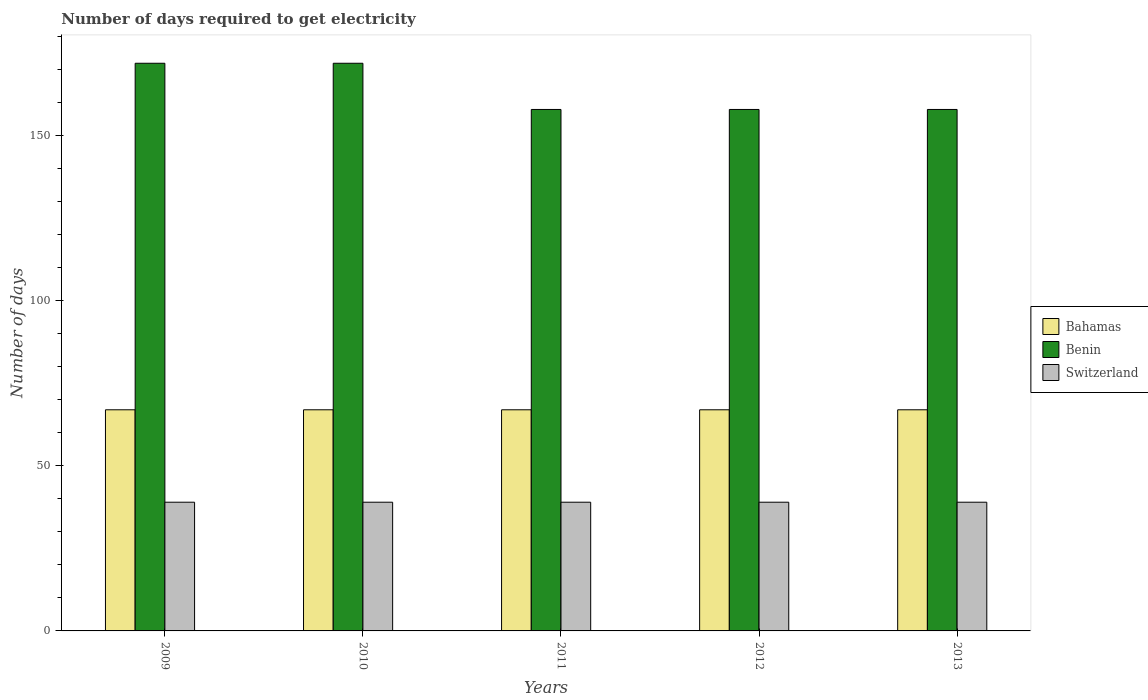How many different coloured bars are there?
Provide a short and direct response. 3. How many groups of bars are there?
Ensure brevity in your answer.  5. How many bars are there on the 3rd tick from the left?
Your response must be concise. 3. What is the number of days required to get electricity in in Benin in 2011?
Your response must be concise. 158. Across all years, what is the maximum number of days required to get electricity in in Bahamas?
Keep it short and to the point. 67. Across all years, what is the minimum number of days required to get electricity in in Bahamas?
Offer a very short reply. 67. What is the total number of days required to get electricity in in Switzerland in the graph?
Give a very brief answer. 195. What is the difference between the number of days required to get electricity in in Benin in 2010 and that in 2012?
Provide a succinct answer. 14. What is the difference between the number of days required to get electricity in in Bahamas in 2011 and the number of days required to get electricity in in Switzerland in 2009?
Offer a terse response. 28. What is the average number of days required to get electricity in in Switzerland per year?
Ensure brevity in your answer.  39. In the year 2012, what is the difference between the number of days required to get electricity in in Benin and number of days required to get electricity in in Switzerland?
Your answer should be compact. 119. In how many years, is the number of days required to get electricity in in Switzerland greater than 140 days?
Ensure brevity in your answer.  0. What is the ratio of the number of days required to get electricity in in Benin in 2010 to that in 2013?
Offer a terse response. 1.09. What is the difference between the highest and the lowest number of days required to get electricity in in Bahamas?
Ensure brevity in your answer.  0. What does the 2nd bar from the left in 2013 represents?
Provide a succinct answer. Benin. What does the 1st bar from the right in 2010 represents?
Make the answer very short. Switzerland. Is it the case that in every year, the sum of the number of days required to get electricity in in Bahamas and number of days required to get electricity in in Benin is greater than the number of days required to get electricity in in Switzerland?
Your answer should be very brief. Yes. How many bars are there?
Make the answer very short. 15. Are all the bars in the graph horizontal?
Your response must be concise. No. How many years are there in the graph?
Your response must be concise. 5. Does the graph contain grids?
Your response must be concise. No. What is the title of the graph?
Your answer should be very brief. Number of days required to get electricity. Does "Oman" appear as one of the legend labels in the graph?
Your answer should be compact. No. What is the label or title of the X-axis?
Provide a succinct answer. Years. What is the label or title of the Y-axis?
Give a very brief answer. Number of days. What is the Number of days in Benin in 2009?
Your answer should be very brief. 172. What is the Number of days in Bahamas in 2010?
Offer a terse response. 67. What is the Number of days in Benin in 2010?
Your answer should be very brief. 172. What is the Number of days of Benin in 2011?
Keep it short and to the point. 158. What is the Number of days of Switzerland in 2011?
Offer a very short reply. 39. What is the Number of days in Bahamas in 2012?
Your answer should be very brief. 67. What is the Number of days of Benin in 2012?
Provide a succinct answer. 158. What is the Number of days of Switzerland in 2012?
Offer a very short reply. 39. What is the Number of days of Benin in 2013?
Give a very brief answer. 158. Across all years, what is the maximum Number of days of Benin?
Make the answer very short. 172. Across all years, what is the minimum Number of days in Benin?
Provide a short and direct response. 158. What is the total Number of days in Bahamas in the graph?
Offer a terse response. 335. What is the total Number of days of Benin in the graph?
Give a very brief answer. 818. What is the total Number of days in Switzerland in the graph?
Your answer should be very brief. 195. What is the difference between the Number of days in Bahamas in 2009 and that in 2010?
Offer a very short reply. 0. What is the difference between the Number of days of Benin in 2009 and that in 2010?
Make the answer very short. 0. What is the difference between the Number of days of Switzerland in 2009 and that in 2010?
Offer a very short reply. 0. What is the difference between the Number of days in Benin in 2009 and that in 2011?
Provide a succinct answer. 14. What is the difference between the Number of days of Benin in 2009 and that in 2012?
Provide a succinct answer. 14. What is the difference between the Number of days of Benin in 2009 and that in 2013?
Provide a succinct answer. 14. What is the difference between the Number of days in Switzerland in 2010 and that in 2011?
Offer a very short reply. 0. What is the difference between the Number of days of Benin in 2010 and that in 2013?
Give a very brief answer. 14. What is the difference between the Number of days of Benin in 2011 and that in 2012?
Your answer should be compact. 0. What is the difference between the Number of days of Benin in 2011 and that in 2013?
Make the answer very short. 0. What is the difference between the Number of days of Switzerland in 2011 and that in 2013?
Offer a terse response. 0. What is the difference between the Number of days of Switzerland in 2012 and that in 2013?
Offer a very short reply. 0. What is the difference between the Number of days in Bahamas in 2009 and the Number of days in Benin in 2010?
Ensure brevity in your answer.  -105. What is the difference between the Number of days in Benin in 2009 and the Number of days in Switzerland in 2010?
Your response must be concise. 133. What is the difference between the Number of days in Bahamas in 2009 and the Number of days in Benin in 2011?
Your response must be concise. -91. What is the difference between the Number of days in Benin in 2009 and the Number of days in Switzerland in 2011?
Keep it short and to the point. 133. What is the difference between the Number of days in Bahamas in 2009 and the Number of days in Benin in 2012?
Your answer should be very brief. -91. What is the difference between the Number of days of Bahamas in 2009 and the Number of days of Switzerland in 2012?
Provide a succinct answer. 28. What is the difference between the Number of days in Benin in 2009 and the Number of days in Switzerland in 2012?
Your answer should be compact. 133. What is the difference between the Number of days in Bahamas in 2009 and the Number of days in Benin in 2013?
Your answer should be very brief. -91. What is the difference between the Number of days of Benin in 2009 and the Number of days of Switzerland in 2013?
Provide a succinct answer. 133. What is the difference between the Number of days of Bahamas in 2010 and the Number of days of Benin in 2011?
Your answer should be compact. -91. What is the difference between the Number of days in Bahamas in 2010 and the Number of days in Switzerland in 2011?
Keep it short and to the point. 28. What is the difference between the Number of days of Benin in 2010 and the Number of days of Switzerland in 2011?
Keep it short and to the point. 133. What is the difference between the Number of days in Bahamas in 2010 and the Number of days in Benin in 2012?
Provide a succinct answer. -91. What is the difference between the Number of days in Bahamas in 2010 and the Number of days in Switzerland in 2012?
Give a very brief answer. 28. What is the difference between the Number of days of Benin in 2010 and the Number of days of Switzerland in 2012?
Keep it short and to the point. 133. What is the difference between the Number of days of Bahamas in 2010 and the Number of days of Benin in 2013?
Offer a terse response. -91. What is the difference between the Number of days in Bahamas in 2010 and the Number of days in Switzerland in 2013?
Your answer should be very brief. 28. What is the difference between the Number of days in Benin in 2010 and the Number of days in Switzerland in 2013?
Keep it short and to the point. 133. What is the difference between the Number of days of Bahamas in 2011 and the Number of days of Benin in 2012?
Your answer should be compact. -91. What is the difference between the Number of days in Benin in 2011 and the Number of days in Switzerland in 2012?
Offer a terse response. 119. What is the difference between the Number of days in Bahamas in 2011 and the Number of days in Benin in 2013?
Provide a succinct answer. -91. What is the difference between the Number of days of Bahamas in 2011 and the Number of days of Switzerland in 2013?
Provide a succinct answer. 28. What is the difference between the Number of days of Benin in 2011 and the Number of days of Switzerland in 2013?
Offer a very short reply. 119. What is the difference between the Number of days of Bahamas in 2012 and the Number of days of Benin in 2013?
Ensure brevity in your answer.  -91. What is the difference between the Number of days of Benin in 2012 and the Number of days of Switzerland in 2013?
Offer a terse response. 119. What is the average Number of days of Bahamas per year?
Your answer should be compact. 67. What is the average Number of days of Benin per year?
Give a very brief answer. 163.6. In the year 2009, what is the difference between the Number of days in Bahamas and Number of days in Benin?
Your answer should be compact. -105. In the year 2009, what is the difference between the Number of days of Bahamas and Number of days of Switzerland?
Provide a short and direct response. 28. In the year 2009, what is the difference between the Number of days of Benin and Number of days of Switzerland?
Your answer should be very brief. 133. In the year 2010, what is the difference between the Number of days in Bahamas and Number of days in Benin?
Make the answer very short. -105. In the year 2010, what is the difference between the Number of days in Bahamas and Number of days in Switzerland?
Keep it short and to the point. 28. In the year 2010, what is the difference between the Number of days of Benin and Number of days of Switzerland?
Ensure brevity in your answer.  133. In the year 2011, what is the difference between the Number of days in Bahamas and Number of days in Benin?
Offer a very short reply. -91. In the year 2011, what is the difference between the Number of days of Benin and Number of days of Switzerland?
Give a very brief answer. 119. In the year 2012, what is the difference between the Number of days of Bahamas and Number of days of Benin?
Give a very brief answer. -91. In the year 2012, what is the difference between the Number of days in Bahamas and Number of days in Switzerland?
Provide a short and direct response. 28. In the year 2012, what is the difference between the Number of days of Benin and Number of days of Switzerland?
Provide a short and direct response. 119. In the year 2013, what is the difference between the Number of days of Bahamas and Number of days of Benin?
Your answer should be compact. -91. In the year 2013, what is the difference between the Number of days of Bahamas and Number of days of Switzerland?
Offer a terse response. 28. In the year 2013, what is the difference between the Number of days in Benin and Number of days in Switzerland?
Make the answer very short. 119. What is the ratio of the Number of days of Bahamas in 2009 to that in 2010?
Offer a very short reply. 1. What is the ratio of the Number of days in Benin in 2009 to that in 2011?
Your answer should be compact. 1.09. What is the ratio of the Number of days in Switzerland in 2009 to that in 2011?
Provide a succinct answer. 1. What is the ratio of the Number of days of Bahamas in 2009 to that in 2012?
Provide a succinct answer. 1. What is the ratio of the Number of days of Benin in 2009 to that in 2012?
Provide a short and direct response. 1.09. What is the ratio of the Number of days of Benin in 2009 to that in 2013?
Offer a terse response. 1.09. What is the ratio of the Number of days of Switzerland in 2009 to that in 2013?
Your answer should be very brief. 1. What is the ratio of the Number of days in Benin in 2010 to that in 2011?
Your answer should be very brief. 1.09. What is the ratio of the Number of days in Bahamas in 2010 to that in 2012?
Provide a short and direct response. 1. What is the ratio of the Number of days of Benin in 2010 to that in 2012?
Provide a succinct answer. 1.09. What is the ratio of the Number of days in Switzerland in 2010 to that in 2012?
Your answer should be compact. 1. What is the ratio of the Number of days in Benin in 2010 to that in 2013?
Your answer should be compact. 1.09. What is the ratio of the Number of days in Switzerland in 2010 to that in 2013?
Offer a terse response. 1. What is the ratio of the Number of days of Bahamas in 2011 to that in 2012?
Ensure brevity in your answer.  1. What is the ratio of the Number of days of Benin in 2011 to that in 2012?
Provide a succinct answer. 1. What is the ratio of the Number of days in Benin in 2011 to that in 2013?
Give a very brief answer. 1. What is the ratio of the Number of days in Switzerland in 2011 to that in 2013?
Your answer should be compact. 1. What is the ratio of the Number of days in Benin in 2012 to that in 2013?
Provide a short and direct response. 1. What is the ratio of the Number of days in Switzerland in 2012 to that in 2013?
Ensure brevity in your answer.  1. What is the difference between the highest and the second highest Number of days in Bahamas?
Your answer should be compact. 0. What is the difference between the highest and the second highest Number of days of Benin?
Make the answer very short. 0. 